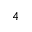Convert formula to latex. <formula><loc_0><loc_0><loc_500><loc_500>^ { 4 }</formula> 